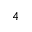Convert formula to latex. <formula><loc_0><loc_0><loc_500><loc_500>^ { 4 }</formula> 